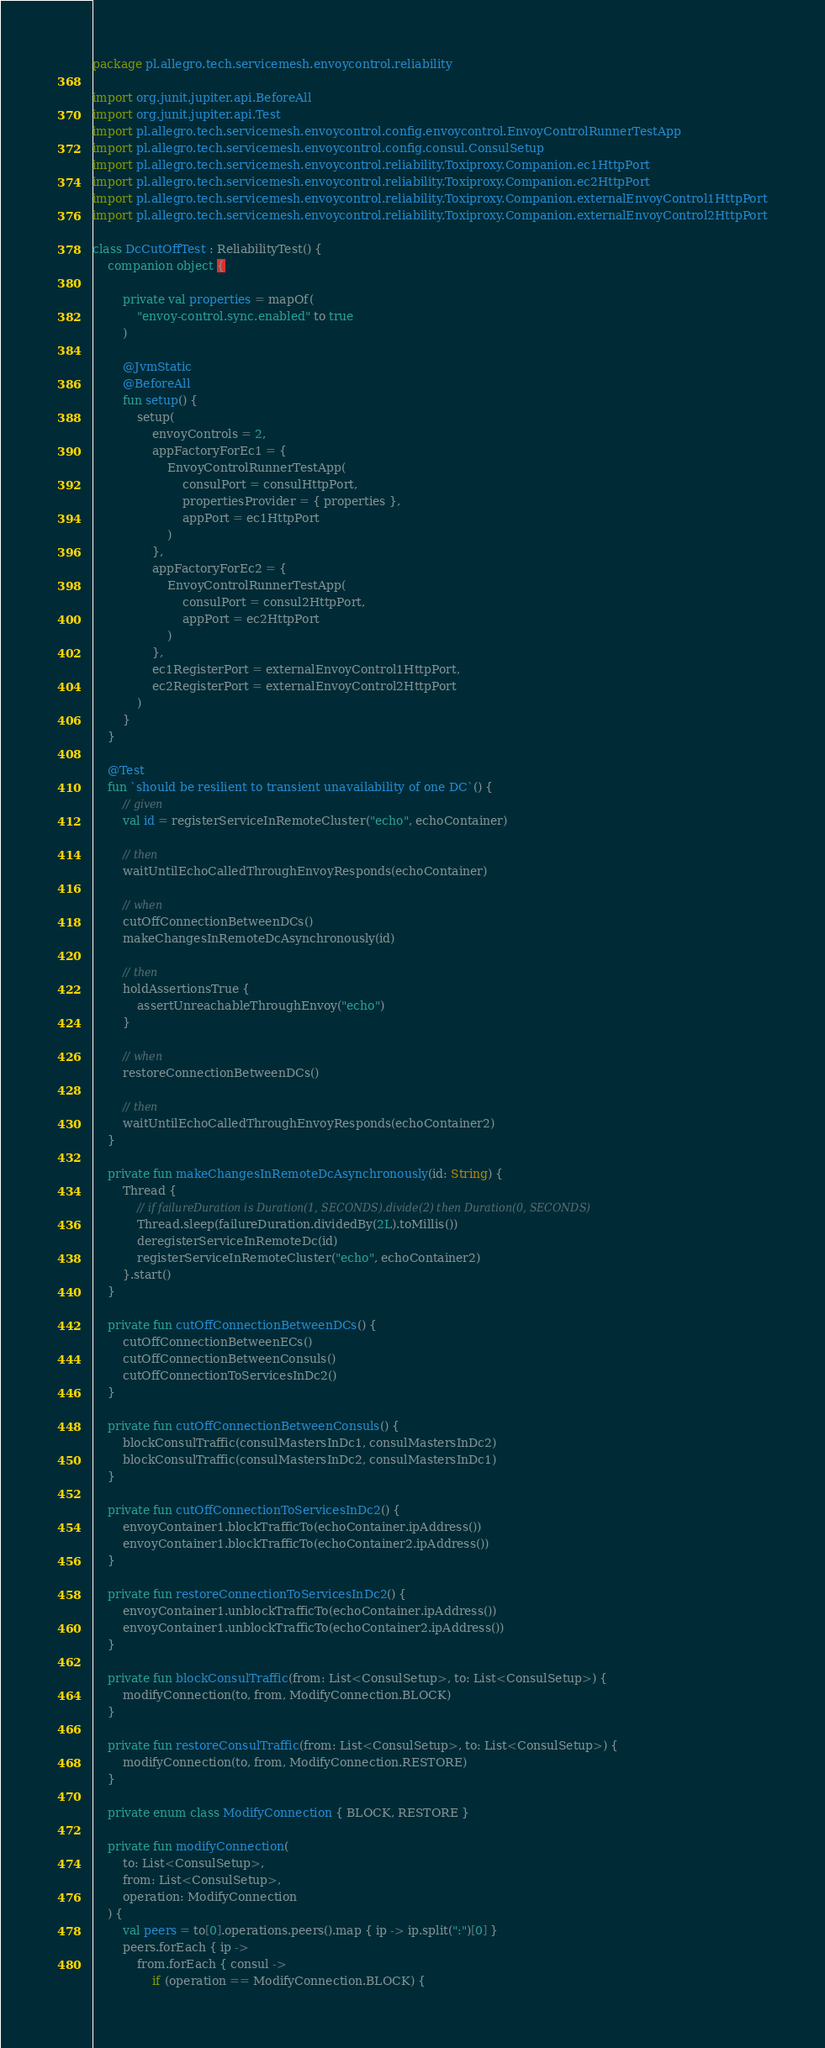<code> <loc_0><loc_0><loc_500><loc_500><_Kotlin_>package pl.allegro.tech.servicemesh.envoycontrol.reliability

import org.junit.jupiter.api.BeforeAll
import org.junit.jupiter.api.Test
import pl.allegro.tech.servicemesh.envoycontrol.config.envoycontrol.EnvoyControlRunnerTestApp
import pl.allegro.tech.servicemesh.envoycontrol.config.consul.ConsulSetup
import pl.allegro.tech.servicemesh.envoycontrol.reliability.Toxiproxy.Companion.ec1HttpPort
import pl.allegro.tech.servicemesh.envoycontrol.reliability.Toxiproxy.Companion.ec2HttpPort
import pl.allegro.tech.servicemesh.envoycontrol.reliability.Toxiproxy.Companion.externalEnvoyControl1HttpPort
import pl.allegro.tech.servicemesh.envoycontrol.reliability.Toxiproxy.Companion.externalEnvoyControl2HttpPort

class DcCutOffTest : ReliabilityTest() {
    companion object {

        private val properties = mapOf(
            "envoy-control.sync.enabled" to true
        )

        @JvmStatic
        @BeforeAll
        fun setup() {
            setup(
                envoyControls = 2,
                appFactoryForEc1 = {
                    EnvoyControlRunnerTestApp(
                        consulPort = consulHttpPort,
                        propertiesProvider = { properties },
                        appPort = ec1HttpPort
                    )
                },
                appFactoryForEc2 = {
                    EnvoyControlRunnerTestApp(
                        consulPort = consul2HttpPort,
                        appPort = ec2HttpPort
                    )
                },
                ec1RegisterPort = externalEnvoyControl1HttpPort,
                ec2RegisterPort = externalEnvoyControl2HttpPort
            )
        }
    }

    @Test
    fun `should be resilient to transient unavailability of one DC`() {
        // given
        val id = registerServiceInRemoteCluster("echo", echoContainer)

        // then
        waitUntilEchoCalledThroughEnvoyResponds(echoContainer)

        // when
        cutOffConnectionBetweenDCs()
        makeChangesInRemoteDcAsynchronously(id)

        // then
        holdAssertionsTrue {
            assertUnreachableThroughEnvoy("echo")
        }

        // when
        restoreConnectionBetweenDCs()

        // then
        waitUntilEchoCalledThroughEnvoyResponds(echoContainer2)
    }

    private fun makeChangesInRemoteDcAsynchronously(id: String) {
        Thread {
            // if failureDuration is Duration(1, SECONDS).divide(2) then Duration(0, SECONDS)
            Thread.sleep(failureDuration.dividedBy(2L).toMillis())
            deregisterServiceInRemoteDc(id)
            registerServiceInRemoteCluster("echo", echoContainer2)
        }.start()
    }

    private fun cutOffConnectionBetweenDCs() {
        cutOffConnectionBetweenECs()
        cutOffConnectionBetweenConsuls()
        cutOffConnectionToServicesInDc2()
    }

    private fun cutOffConnectionBetweenConsuls() {
        blockConsulTraffic(consulMastersInDc1, consulMastersInDc2)
        blockConsulTraffic(consulMastersInDc2, consulMastersInDc1)
    }

    private fun cutOffConnectionToServicesInDc2() {
        envoyContainer1.blockTrafficTo(echoContainer.ipAddress())
        envoyContainer1.blockTrafficTo(echoContainer2.ipAddress())
    }

    private fun restoreConnectionToServicesInDc2() {
        envoyContainer1.unblockTrafficTo(echoContainer.ipAddress())
        envoyContainer1.unblockTrafficTo(echoContainer2.ipAddress())
    }

    private fun blockConsulTraffic(from: List<ConsulSetup>, to: List<ConsulSetup>) {
        modifyConnection(to, from, ModifyConnection.BLOCK)
    }

    private fun restoreConsulTraffic(from: List<ConsulSetup>, to: List<ConsulSetup>) {
        modifyConnection(to, from, ModifyConnection.RESTORE)
    }

    private enum class ModifyConnection { BLOCK, RESTORE }

    private fun modifyConnection(
        to: List<ConsulSetup>,
        from: List<ConsulSetup>,
        operation: ModifyConnection
    ) {
        val peers = to[0].operations.peers().map { ip -> ip.split(":")[0] }
        peers.forEach { ip ->
            from.forEach { consul ->
                if (operation == ModifyConnection.BLOCK) {</code> 